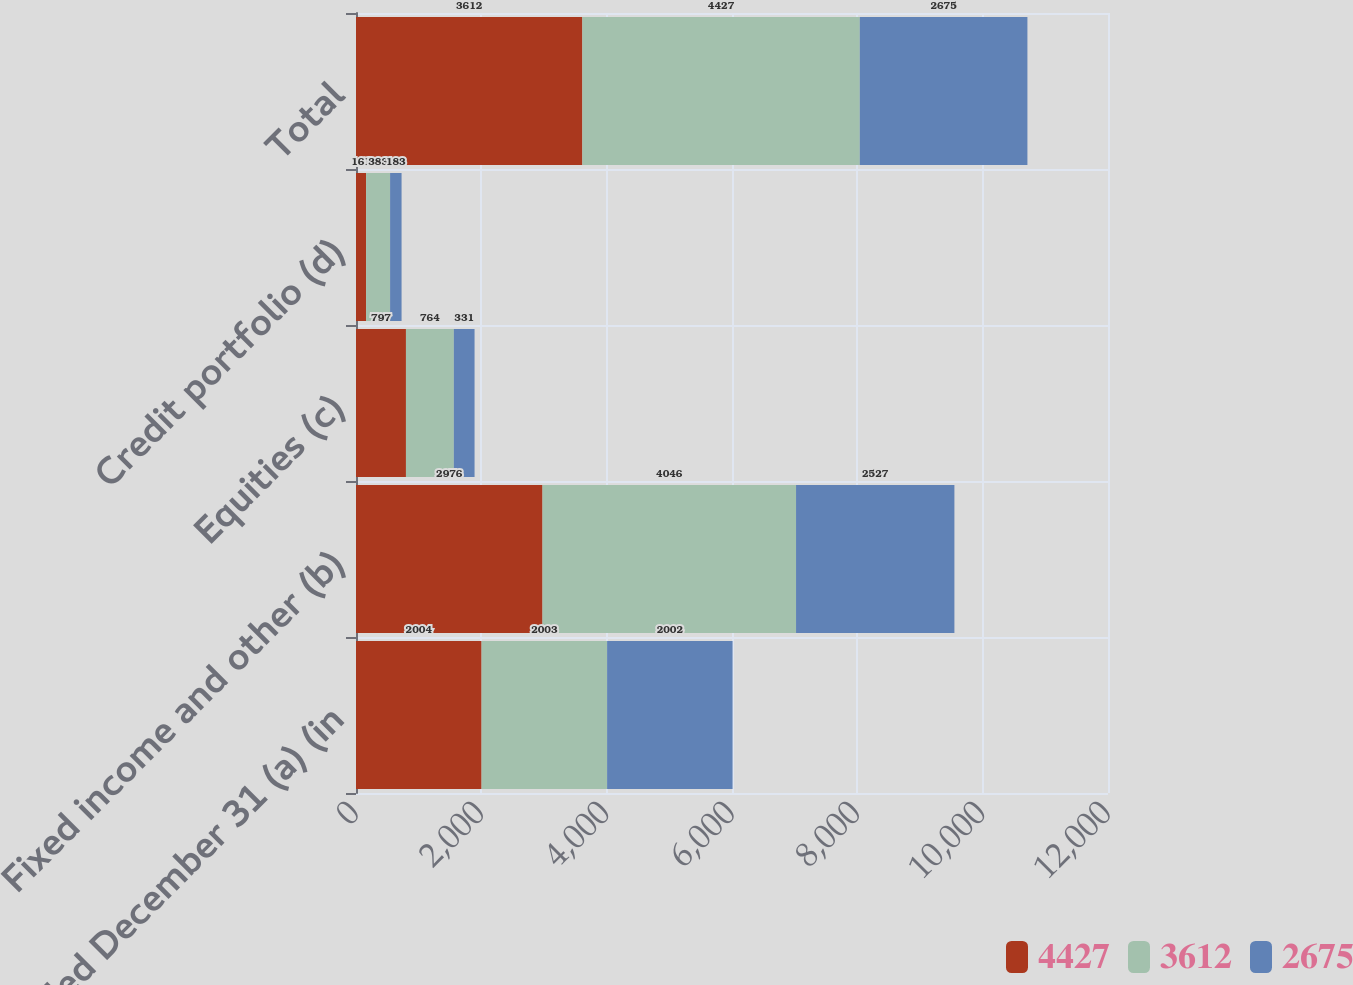Convert chart. <chart><loc_0><loc_0><loc_500><loc_500><stacked_bar_chart><ecel><fcel>Year ended December 31 (a) (in<fcel>Fixed income and other (b)<fcel>Equities (c)<fcel>Credit portfolio (d)<fcel>Total<nl><fcel>4427<fcel>2004<fcel>2976<fcel>797<fcel>161<fcel>3612<nl><fcel>3612<fcel>2003<fcel>4046<fcel>764<fcel>383<fcel>4427<nl><fcel>2675<fcel>2002<fcel>2527<fcel>331<fcel>183<fcel>2675<nl></chart> 